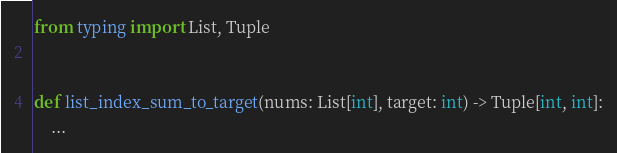Convert code to text. <code><loc_0><loc_0><loc_500><loc_500><_Python_>from typing import List, Tuple


def list_index_sum_to_target(nums: List[int], target: int) -> Tuple[int, int]:
    ...

</code> 